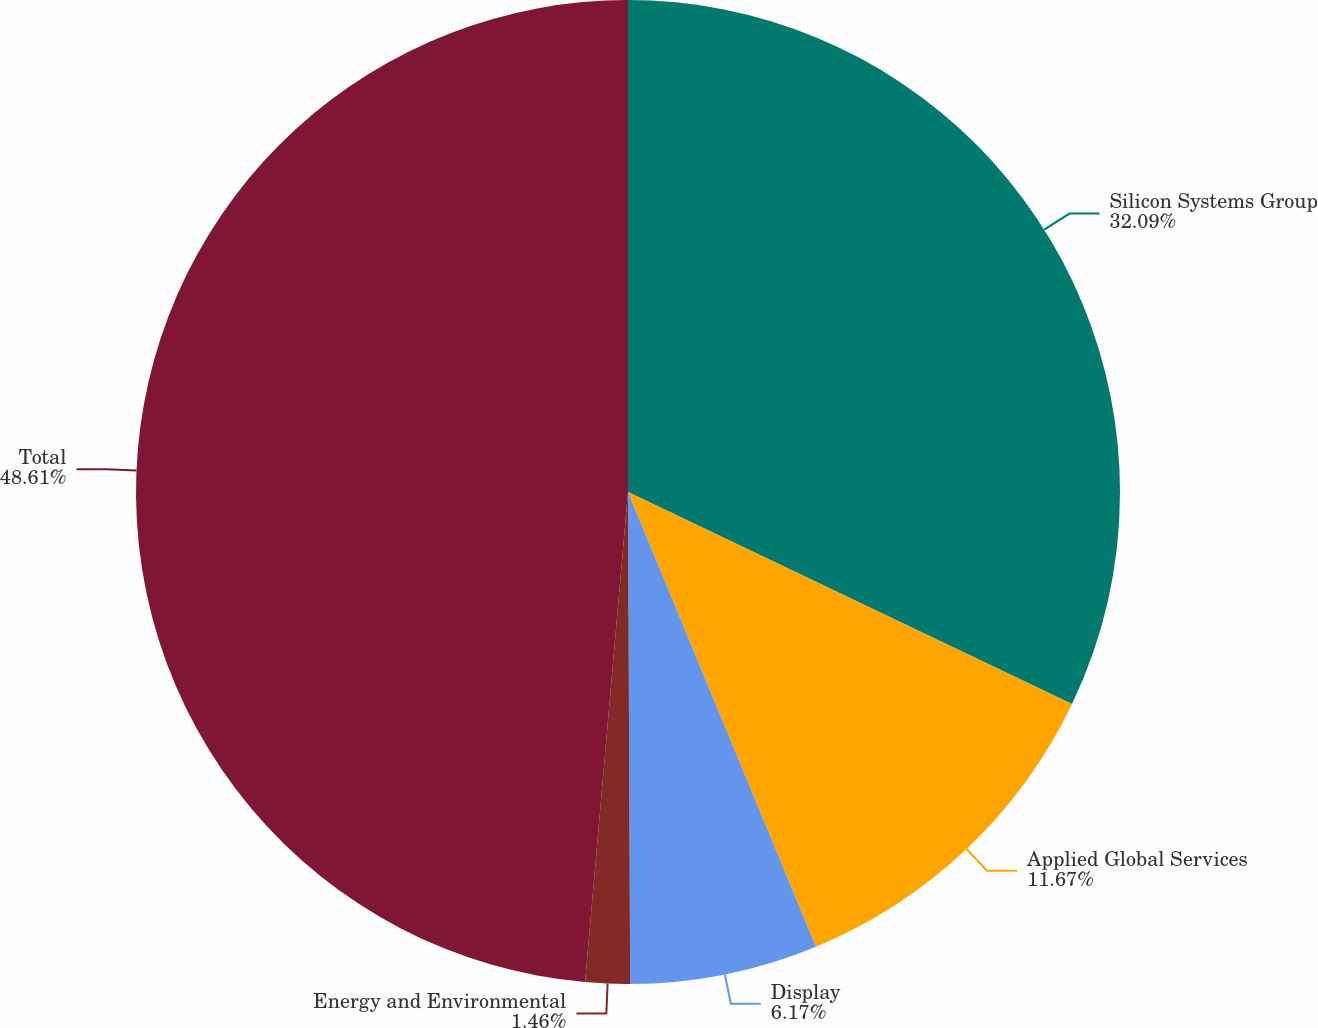Convert chart to OTSL. <chart><loc_0><loc_0><loc_500><loc_500><pie_chart><fcel>Silicon Systems Group<fcel>Applied Global Services<fcel>Display<fcel>Energy and Environmental<fcel>Total<nl><fcel>32.09%<fcel>11.67%<fcel>6.17%<fcel>1.46%<fcel>48.61%<nl></chart> 